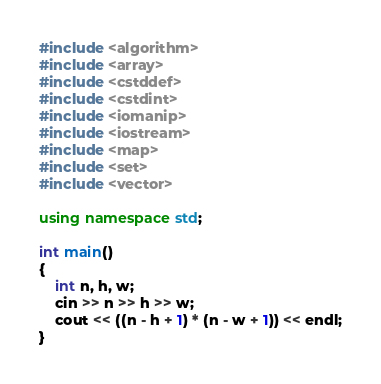Convert code to text. <code><loc_0><loc_0><loc_500><loc_500><_C++_>#include <algorithm>
#include <array>
#include <cstddef>
#include <cstdint>
#include <iomanip>
#include <iostream>
#include <map>
#include <set>
#include <vector>

using namespace std;

int main()
{
    int n, h, w;
    cin >> n >> h >> w;
    cout << ((n - h + 1) * (n - w + 1)) << endl;
}
</code> 